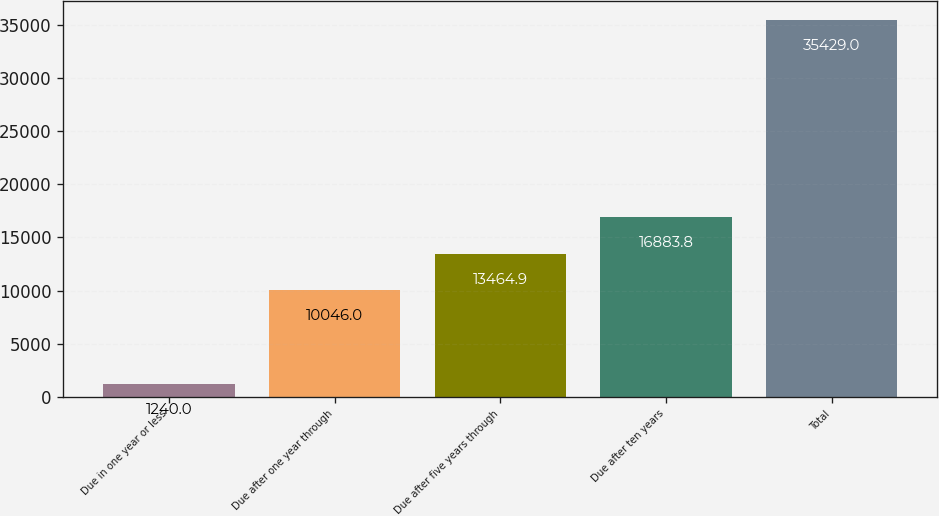<chart> <loc_0><loc_0><loc_500><loc_500><bar_chart><fcel>Due in one year or less<fcel>Due after one year through<fcel>Due after five years through<fcel>Due after ten years<fcel>Total<nl><fcel>1240<fcel>10046<fcel>13464.9<fcel>16883.8<fcel>35429<nl></chart> 